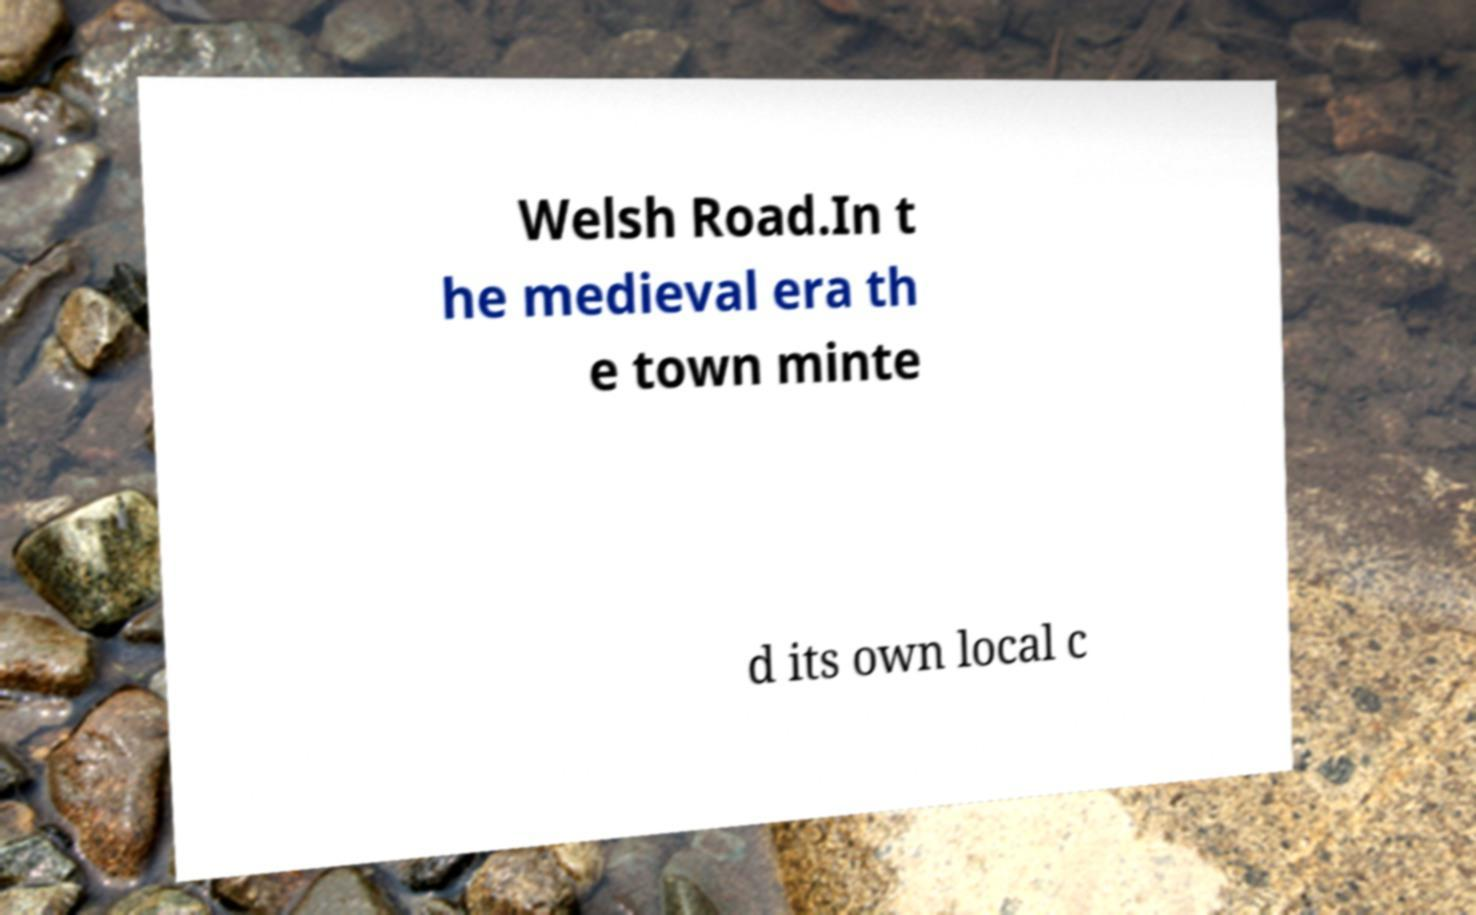Can you read and provide the text displayed in the image?This photo seems to have some interesting text. Can you extract and type it out for me? Welsh Road.In t he medieval era th e town minte d its own local c 